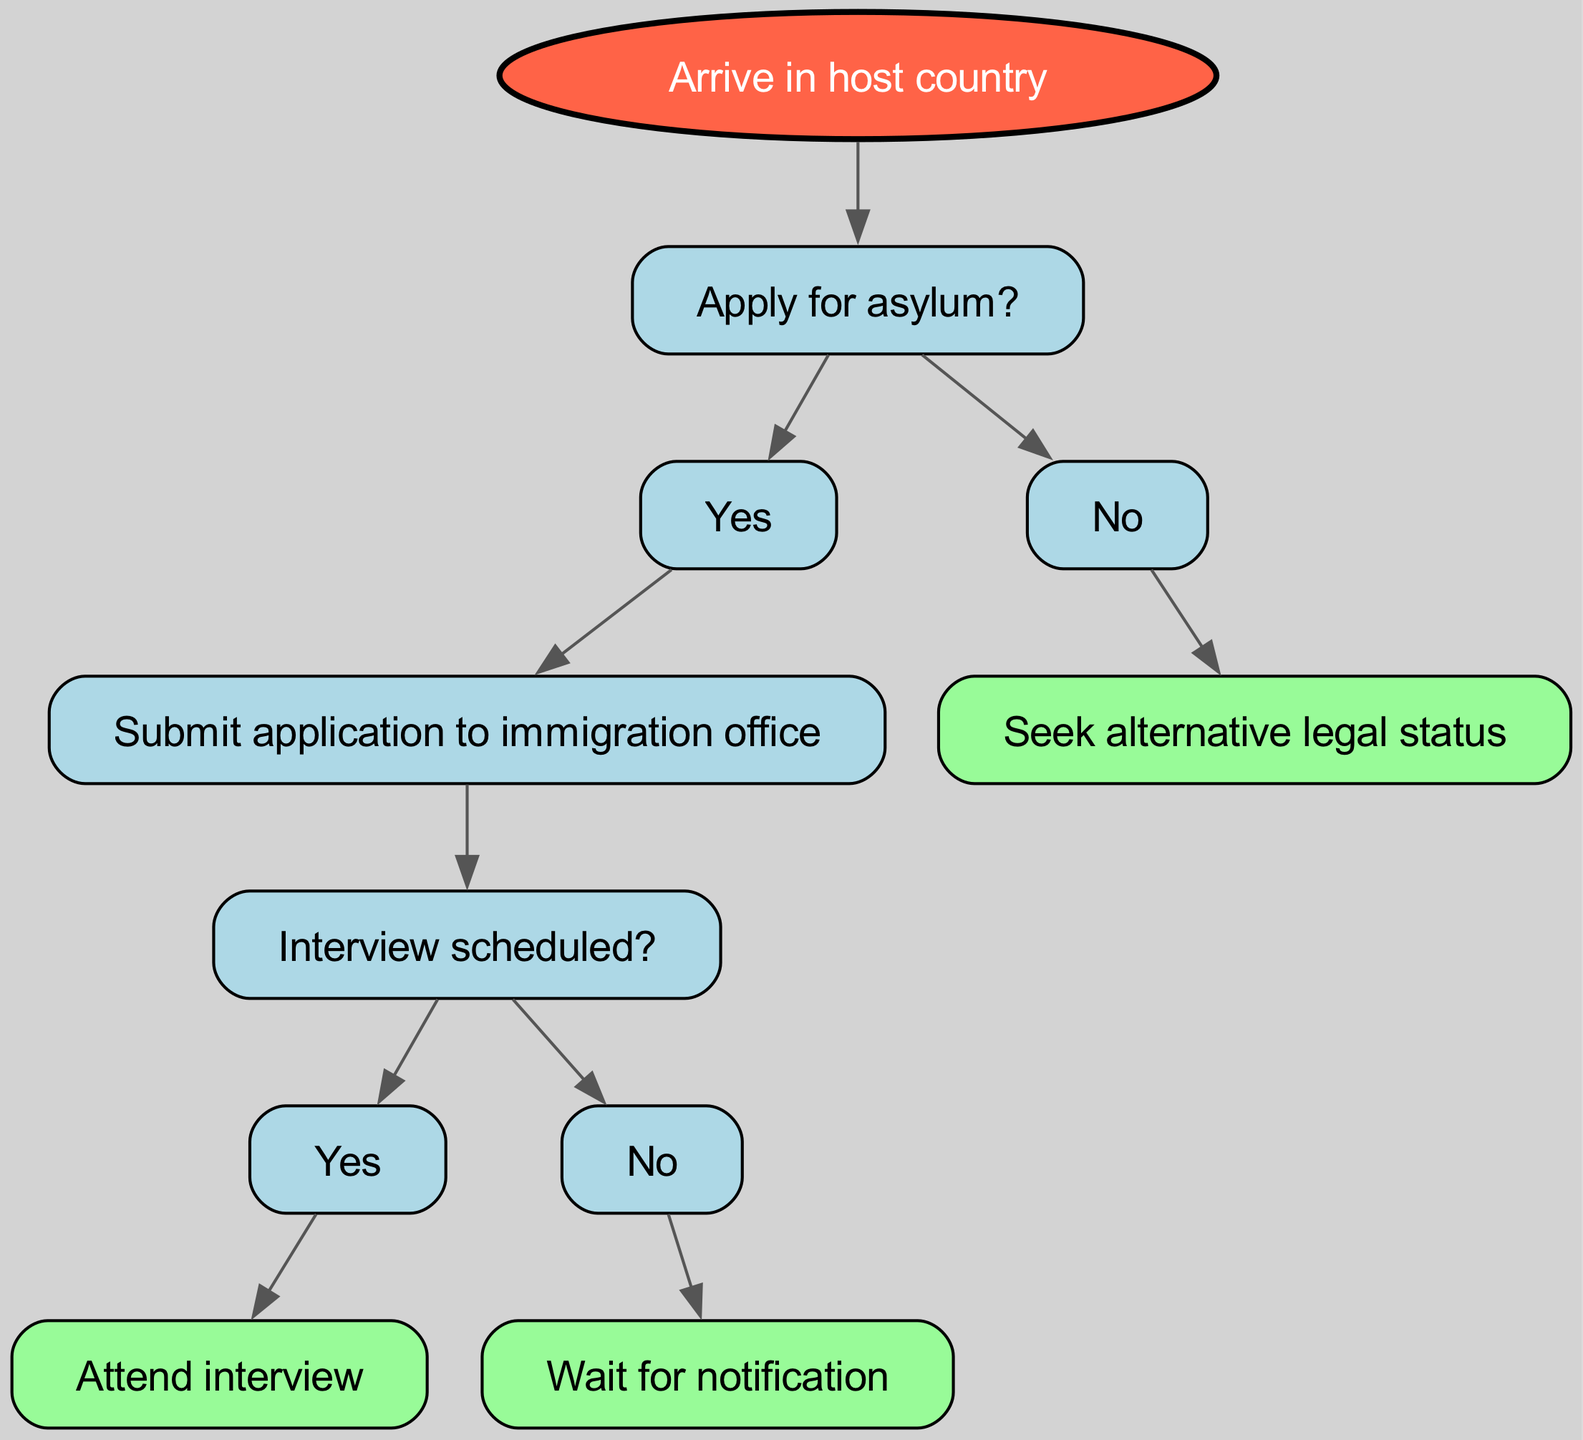What is the first action to take upon arriving in the host country? According to the diagram, the first action after arriving in the host country is to apply for asylum. This is specified at the root node of the decision tree.
Answer: Apply for asylum How many main decisions are presented in the decision tree? The decision tree presents two main decisions stemming from whether to apply for asylum: "Yes" and "No." Each of these options leads to further steps.
Answer: Two What happens after submitting the application to the immigration office? After submitting the application to the immigration office, the next step is for an interview to be scheduled. This is found in the child node of the "Submit application to immigration office" node.
Answer: Interview scheduled If the interview is scheduled, what is the next step? If the interview is scheduled, the next step is to attend the interview. This is outlined in the child node of the "Interview scheduled?" node when the answer is "Yes."
Answer: Attend interview What is the alternative option if someone decides not to apply for asylum? If someone decides not to apply for asylum, the alternative option is to seek alternative legal status. This is specified in the branch for the "No" decision under "Apply for asylum?"
Answer: Seek alternative legal status What is the final outcome if there is no interview scheduled? If there is no interview scheduled, the final outcome is to wait for notification. This conclusion is reached in the branch that follows when the answer is "No" under "Interview scheduled?"
Answer: Wait for notification What type of node represents the decision to apply for asylum? The decision to apply for asylum is represented as a rectangular node in the decision tree, indicating that it is a decision point in the process.
Answer: Rectangular node How many actions are required after deciding to apply for asylum? There are two actions required after deciding to apply for asylum: submitting the application and attending the interview (if scheduled). This can be tracked through the flow of the decision tree from the "Yes" branch.
Answer: Two actions 